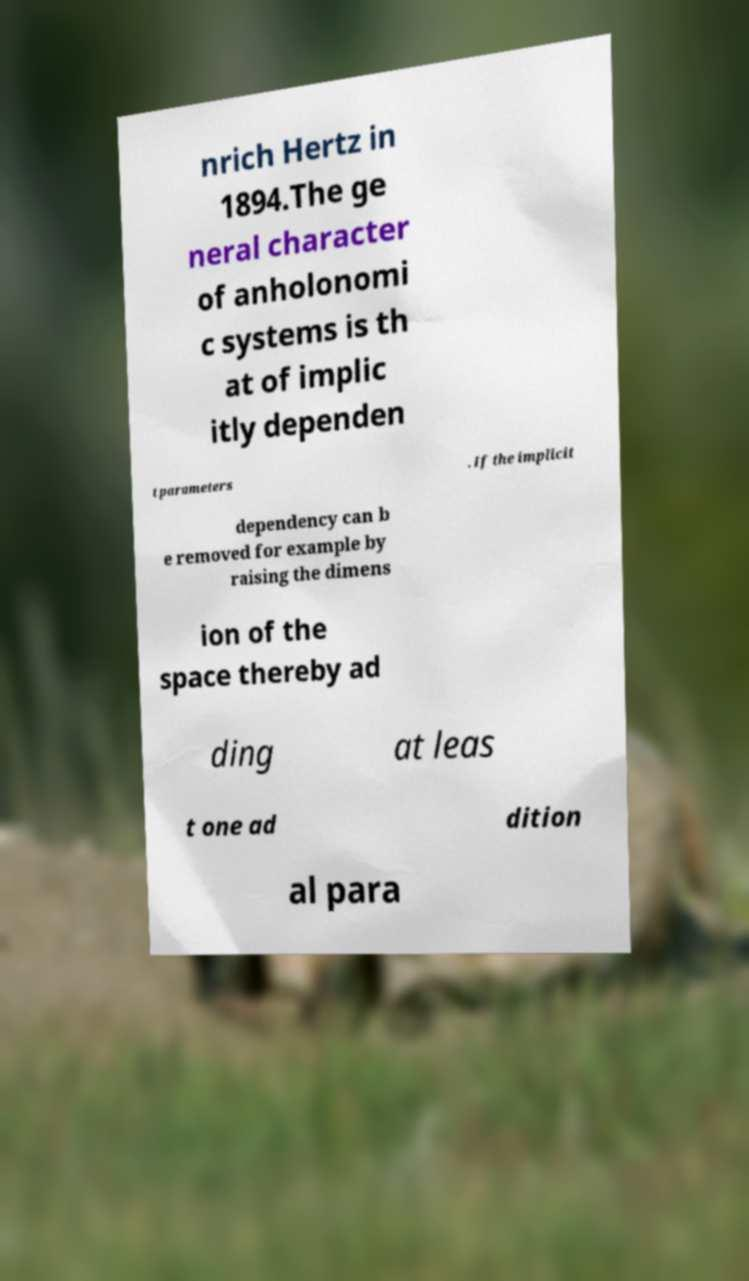What messages or text are displayed in this image? I need them in a readable, typed format. nrich Hertz in 1894.The ge neral character of anholonomi c systems is th at of implic itly dependen t parameters . If the implicit dependency can b e removed for example by raising the dimens ion of the space thereby ad ding at leas t one ad dition al para 